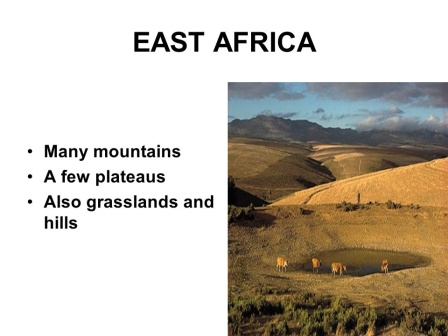Describe the following image. The image presents a sweeping vista of East Africa from a high vantage point. Dominated by an expansive valley, the landscape is an intricate patchwork of grasslands, rolling hills, and the occasional plateau, with majestic mountains forming a serene backdrop in the distance. The sky is a canvas of clear blue, interspersed with soft, scattered clouds gently floating on the horizon. In the immediate foreground, five elephants, their light brown forms contrasting vividly against the lush greens, are seen walking in a single file along a meandering dirt path. They follow their leader with a stately grace, effortlessly commanding the scenery with their massive presence. Bold black text at the top states 'EAST AFRICA,' emphasizing the location's natural grandeur in a simple yet powerful declaration. The image serves as a stunning testament to the diverse and breathtaking beauty of East Africa. 